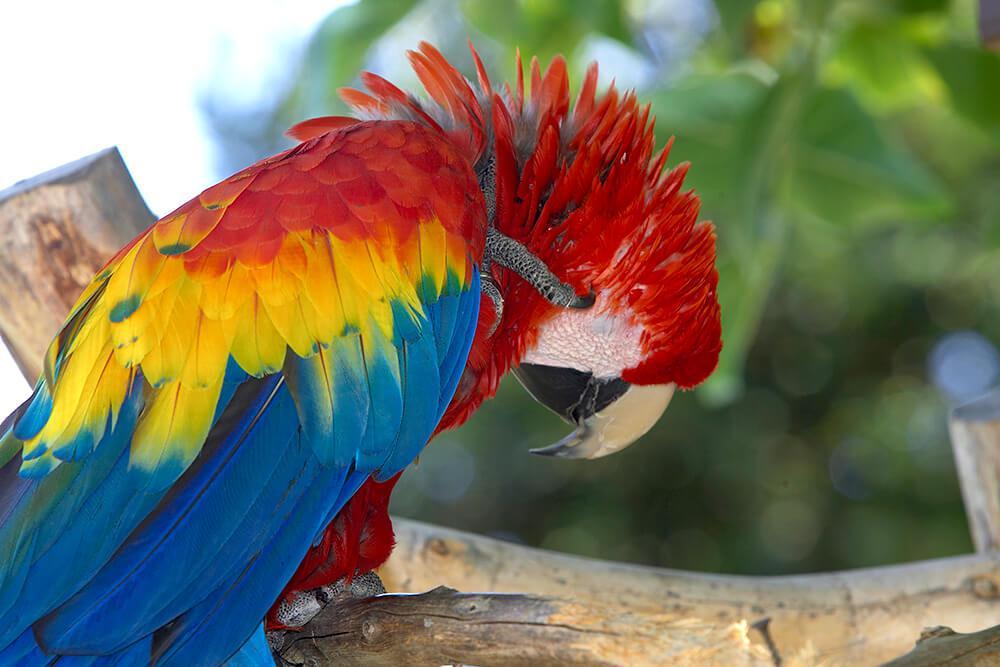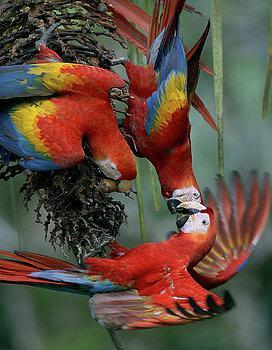The first image is the image on the left, the second image is the image on the right. For the images displayed, is the sentence "There are no more than 2 birds in each image." factually correct? Answer yes or no. No. 